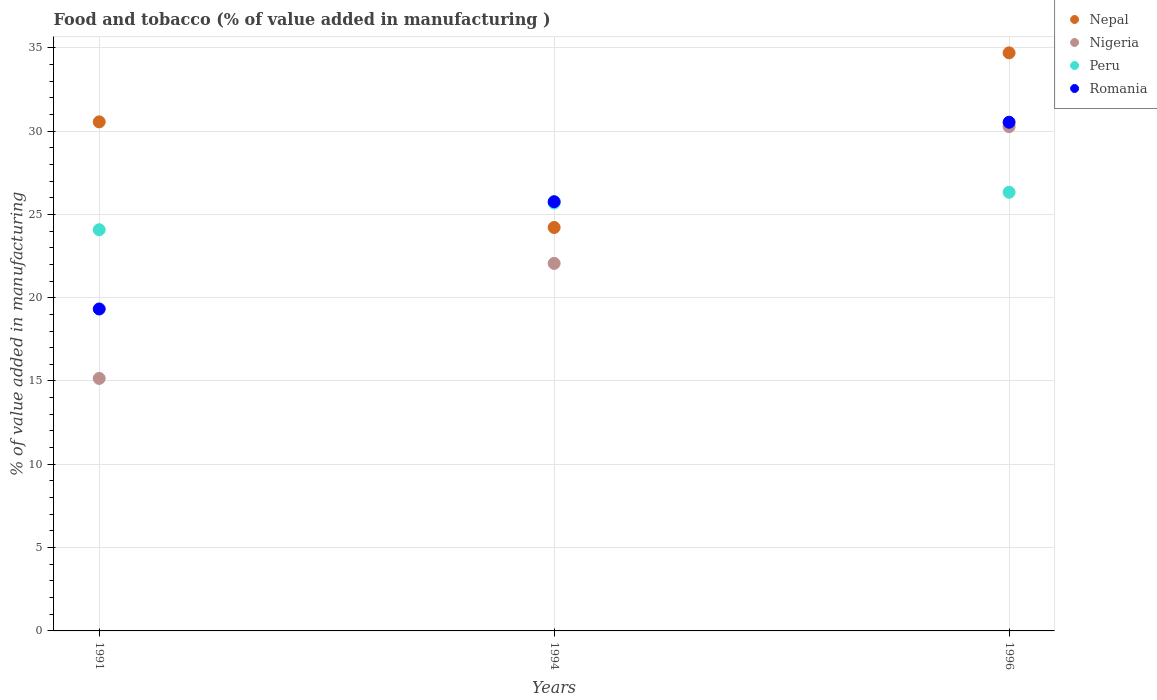How many different coloured dotlines are there?
Your response must be concise. 4. What is the value added in manufacturing food and tobacco in Nepal in 1991?
Your answer should be very brief. 30.55. Across all years, what is the maximum value added in manufacturing food and tobacco in Nigeria?
Your answer should be very brief. 30.27. Across all years, what is the minimum value added in manufacturing food and tobacco in Nigeria?
Provide a succinct answer. 15.15. In which year was the value added in manufacturing food and tobacco in Romania maximum?
Your answer should be very brief. 1996. In which year was the value added in manufacturing food and tobacco in Peru minimum?
Offer a terse response. 1991. What is the total value added in manufacturing food and tobacco in Peru in the graph?
Keep it short and to the point. 76.08. What is the difference between the value added in manufacturing food and tobacco in Nigeria in 1991 and that in 1994?
Ensure brevity in your answer.  -6.9. What is the difference between the value added in manufacturing food and tobacco in Nigeria in 1991 and the value added in manufacturing food and tobacco in Romania in 1996?
Provide a short and direct response. -15.38. What is the average value added in manufacturing food and tobacco in Nepal per year?
Provide a succinct answer. 29.82. In the year 1991, what is the difference between the value added in manufacturing food and tobacco in Romania and value added in manufacturing food and tobacco in Nigeria?
Your answer should be very brief. 4.17. What is the ratio of the value added in manufacturing food and tobacco in Peru in 1994 to that in 1996?
Give a very brief answer. 0.98. Is the difference between the value added in manufacturing food and tobacco in Romania in 1991 and 1994 greater than the difference between the value added in manufacturing food and tobacco in Nigeria in 1991 and 1994?
Provide a succinct answer. Yes. What is the difference between the highest and the second highest value added in manufacturing food and tobacco in Peru?
Offer a terse response. 0.65. What is the difference between the highest and the lowest value added in manufacturing food and tobacco in Nigeria?
Make the answer very short. 15.11. In how many years, is the value added in manufacturing food and tobacco in Romania greater than the average value added in manufacturing food and tobacco in Romania taken over all years?
Provide a succinct answer. 2. Is the sum of the value added in manufacturing food and tobacco in Nepal in 1991 and 1996 greater than the maximum value added in manufacturing food and tobacco in Nigeria across all years?
Offer a very short reply. Yes. Is it the case that in every year, the sum of the value added in manufacturing food and tobacco in Romania and value added in manufacturing food and tobacco in Peru  is greater than the value added in manufacturing food and tobacco in Nigeria?
Provide a succinct answer. Yes. Does the value added in manufacturing food and tobacco in Peru monotonically increase over the years?
Offer a very short reply. Yes. Is the value added in manufacturing food and tobacco in Nepal strictly greater than the value added in manufacturing food and tobacco in Peru over the years?
Offer a very short reply. No. Is the value added in manufacturing food and tobacco in Nepal strictly less than the value added in manufacturing food and tobacco in Nigeria over the years?
Your response must be concise. No. How many dotlines are there?
Ensure brevity in your answer.  4. How many years are there in the graph?
Provide a succinct answer. 3. What is the difference between two consecutive major ticks on the Y-axis?
Provide a short and direct response. 5. Does the graph contain grids?
Provide a short and direct response. Yes. Where does the legend appear in the graph?
Offer a terse response. Top right. How many legend labels are there?
Ensure brevity in your answer.  4. How are the legend labels stacked?
Offer a very short reply. Vertical. What is the title of the graph?
Offer a terse response. Food and tobacco (% of value added in manufacturing ). Does "Malawi" appear as one of the legend labels in the graph?
Keep it short and to the point. No. What is the label or title of the X-axis?
Your response must be concise. Years. What is the label or title of the Y-axis?
Make the answer very short. % of value added in manufacturing. What is the % of value added in manufacturing in Nepal in 1991?
Offer a very short reply. 30.55. What is the % of value added in manufacturing of Nigeria in 1991?
Your answer should be very brief. 15.15. What is the % of value added in manufacturing of Peru in 1991?
Your answer should be very brief. 24.08. What is the % of value added in manufacturing of Romania in 1991?
Offer a very short reply. 19.32. What is the % of value added in manufacturing of Nepal in 1994?
Your answer should be very brief. 24.21. What is the % of value added in manufacturing of Nigeria in 1994?
Give a very brief answer. 22.06. What is the % of value added in manufacturing in Peru in 1994?
Give a very brief answer. 25.68. What is the % of value added in manufacturing of Romania in 1994?
Offer a very short reply. 25.76. What is the % of value added in manufacturing of Nepal in 1996?
Give a very brief answer. 34.69. What is the % of value added in manufacturing of Nigeria in 1996?
Offer a very short reply. 30.27. What is the % of value added in manufacturing in Peru in 1996?
Offer a terse response. 26.33. What is the % of value added in manufacturing of Romania in 1996?
Your answer should be compact. 30.53. Across all years, what is the maximum % of value added in manufacturing in Nepal?
Your answer should be very brief. 34.69. Across all years, what is the maximum % of value added in manufacturing of Nigeria?
Provide a short and direct response. 30.27. Across all years, what is the maximum % of value added in manufacturing of Peru?
Ensure brevity in your answer.  26.33. Across all years, what is the maximum % of value added in manufacturing in Romania?
Provide a short and direct response. 30.53. Across all years, what is the minimum % of value added in manufacturing in Nepal?
Give a very brief answer. 24.21. Across all years, what is the minimum % of value added in manufacturing in Nigeria?
Your answer should be compact. 15.15. Across all years, what is the minimum % of value added in manufacturing of Peru?
Offer a terse response. 24.08. Across all years, what is the minimum % of value added in manufacturing in Romania?
Ensure brevity in your answer.  19.32. What is the total % of value added in manufacturing of Nepal in the graph?
Offer a terse response. 89.46. What is the total % of value added in manufacturing in Nigeria in the graph?
Offer a terse response. 67.48. What is the total % of value added in manufacturing of Peru in the graph?
Offer a terse response. 76.08. What is the total % of value added in manufacturing in Romania in the graph?
Provide a short and direct response. 75.61. What is the difference between the % of value added in manufacturing in Nepal in 1991 and that in 1994?
Provide a short and direct response. 6.34. What is the difference between the % of value added in manufacturing in Nigeria in 1991 and that in 1994?
Keep it short and to the point. -6.9. What is the difference between the % of value added in manufacturing in Peru in 1991 and that in 1994?
Ensure brevity in your answer.  -1.6. What is the difference between the % of value added in manufacturing of Romania in 1991 and that in 1994?
Give a very brief answer. -6.44. What is the difference between the % of value added in manufacturing of Nepal in 1991 and that in 1996?
Offer a very short reply. -4.14. What is the difference between the % of value added in manufacturing in Nigeria in 1991 and that in 1996?
Provide a succinct answer. -15.11. What is the difference between the % of value added in manufacturing in Peru in 1991 and that in 1996?
Keep it short and to the point. -2.25. What is the difference between the % of value added in manufacturing of Romania in 1991 and that in 1996?
Provide a short and direct response. -11.21. What is the difference between the % of value added in manufacturing of Nepal in 1994 and that in 1996?
Ensure brevity in your answer.  -10.48. What is the difference between the % of value added in manufacturing of Nigeria in 1994 and that in 1996?
Your answer should be very brief. -8.21. What is the difference between the % of value added in manufacturing of Peru in 1994 and that in 1996?
Make the answer very short. -0.65. What is the difference between the % of value added in manufacturing of Romania in 1994 and that in 1996?
Keep it short and to the point. -4.77. What is the difference between the % of value added in manufacturing of Nepal in 1991 and the % of value added in manufacturing of Nigeria in 1994?
Offer a very short reply. 8.5. What is the difference between the % of value added in manufacturing of Nepal in 1991 and the % of value added in manufacturing of Peru in 1994?
Provide a short and direct response. 4.87. What is the difference between the % of value added in manufacturing in Nepal in 1991 and the % of value added in manufacturing in Romania in 1994?
Your answer should be compact. 4.79. What is the difference between the % of value added in manufacturing in Nigeria in 1991 and the % of value added in manufacturing in Peru in 1994?
Make the answer very short. -10.53. What is the difference between the % of value added in manufacturing in Nigeria in 1991 and the % of value added in manufacturing in Romania in 1994?
Provide a short and direct response. -10.61. What is the difference between the % of value added in manufacturing in Peru in 1991 and the % of value added in manufacturing in Romania in 1994?
Keep it short and to the point. -1.68. What is the difference between the % of value added in manufacturing of Nepal in 1991 and the % of value added in manufacturing of Nigeria in 1996?
Your response must be concise. 0.29. What is the difference between the % of value added in manufacturing in Nepal in 1991 and the % of value added in manufacturing in Peru in 1996?
Your answer should be compact. 4.23. What is the difference between the % of value added in manufacturing of Nepal in 1991 and the % of value added in manufacturing of Romania in 1996?
Offer a very short reply. 0.02. What is the difference between the % of value added in manufacturing of Nigeria in 1991 and the % of value added in manufacturing of Peru in 1996?
Keep it short and to the point. -11.17. What is the difference between the % of value added in manufacturing of Nigeria in 1991 and the % of value added in manufacturing of Romania in 1996?
Provide a succinct answer. -15.38. What is the difference between the % of value added in manufacturing in Peru in 1991 and the % of value added in manufacturing in Romania in 1996?
Provide a short and direct response. -6.45. What is the difference between the % of value added in manufacturing in Nepal in 1994 and the % of value added in manufacturing in Nigeria in 1996?
Make the answer very short. -6.05. What is the difference between the % of value added in manufacturing of Nepal in 1994 and the % of value added in manufacturing of Peru in 1996?
Provide a succinct answer. -2.11. What is the difference between the % of value added in manufacturing in Nepal in 1994 and the % of value added in manufacturing in Romania in 1996?
Keep it short and to the point. -6.32. What is the difference between the % of value added in manufacturing in Nigeria in 1994 and the % of value added in manufacturing in Peru in 1996?
Give a very brief answer. -4.27. What is the difference between the % of value added in manufacturing of Nigeria in 1994 and the % of value added in manufacturing of Romania in 1996?
Provide a succinct answer. -8.47. What is the difference between the % of value added in manufacturing of Peru in 1994 and the % of value added in manufacturing of Romania in 1996?
Offer a very short reply. -4.85. What is the average % of value added in manufacturing in Nepal per year?
Keep it short and to the point. 29.82. What is the average % of value added in manufacturing in Nigeria per year?
Provide a succinct answer. 22.49. What is the average % of value added in manufacturing of Peru per year?
Offer a very short reply. 25.36. What is the average % of value added in manufacturing in Romania per year?
Give a very brief answer. 25.2. In the year 1991, what is the difference between the % of value added in manufacturing of Nepal and % of value added in manufacturing of Nigeria?
Offer a terse response. 15.4. In the year 1991, what is the difference between the % of value added in manufacturing of Nepal and % of value added in manufacturing of Peru?
Keep it short and to the point. 6.48. In the year 1991, what is the difference between the % of value added in manufacturing of Nepal and % of value added in manufacturing of Romania?
Make the answer very short. 11.23. In the year 1991, what is the difference between the % of value added in manufacturing in Nigeria and % of value added in manufacturing in Peru?
Keep it short and to the point. -8.92. In the year 1991, what is the difference between the % of value added in manufacturing in Nigeria and % of value added in manufacturing in Romania?
Make the answer very short. -4.17. In the year 1991, what is the difference between the % of value added in manufacturing in Peru and % of value added in manufacturing in Romania?
Your answer should be very brief. 4.76. In the year 1994, what is the difference between the % of value added in manufacturing in Nepal and % of value added in manufacturing in Nigeria?
Your response must be concise. 2.16. In the year 1994, what is the difference between the % of value added in manufacturing of Nepal and % of value added in manufacturing of Peru?
Offer a terse response. -1.47. In the year 1994, what is the difference between the % of value added in manufacturing of Nepal and % of value added in manufacturing of Romania?
Make the answer very short. -1.55. In the year 1994, what is the difference between the % of value added in manufacturing of Nigeria and % of value added in manufacturing of Peru?
Ensure brevity in your answer.  -3.62. In the year 1994, what is the difference between the % of value added in manufacturing in Nigeria and % of value added in manufacturing in Romania?
Your response must be concise. -3.7. In the year 1994, what is the difference between the % of value added in manufacturing in Peru and % of value added in manufacturing in Romania?
Provide a short and direct response. -0.08. In the year 1996, what is the difference between the % of value added in manufacturing of Nepal and % of value added in manufacturing of Nigeria?
Your answer should be compact. 4.43. In the year 1996, what is the difference between the % of value added in manufacturing in Nepal and % of value added in manufacturing in Peru?
Ensure brevity in your answer.  8.37. In the year 1996, what is the difference between the % of value added in manufacturing in Nepal and % of value added in manufacturing in Romania?
Give a very brief answer. 4.16. In the year 1996, what is the difference between the % of value added in manufacturing in Nigeria and % of value added in manufacturing in Peru?
Your answer should be very brief. 3.94. In the year 1996, what is the difference between the % of value added in manufacturing in Nigeria and % of value added in manufacturing in Romania?
Ensure brevity in your answer.  -0.26. In the year 1996, what is the difference between the % of value added in manufacturing in Peru and % of value added in manufacturing in Romania?
Keep it short and to the point. -4.2. What is the ratio of the % of value added in manufacturing in Nepal in 1991 to that in 1994?
Offer a very short reply. 1.26. What is the ratio of the % of value added in manufacturing in Nigeria in 1991 to that in 1994?
Give a very brief answer. 0.69. What is the ratio of the % of value added in manufacturing in Peru in 1991 to that in 1994?
Your response must be concise. 0.94. What is the ratio of the % of value added in manufacturing of Romania in 1991 to that in 1994?
Your answer should be compact. 0.75. What is the ratio of the % of value added in manufacturing in Nepal in 1991 to that in 1996?
Offer a terse response. 0.88. What is the ratio of the % of value added in manufacturing in Nigeria in 1991 to that in 1996?
Offer a terse response. 0.5. What is the ratio of the % of value added in manufacturing of Peru in 1991 to that in 1996?
Give a very brief answer. 0.91. What is the ratio of the % of value added in manufacturing of Romania in 1991 to that in 1996?
Your response must be concise. 0.63. What is the ratio of the % of value added in manufacturing in Nepal in 1994 to that in 1996?
Offer a very short reply. 0.7. What is the ratio of the % of value added in manufacturing in Nigeria in 1994 to that in 1996?
Give a very brief answer. 0.73. What is the ratio of the % of value added in manufacturing in Peru in 1994 to that in 1996?
Give a very brief answer. 0.98. What is the ratio of the % of value added in manufacturing in Romania in 1994 to that in 1996?
Give a very brief answer. 0.84. What is the difference between the highest and the second highest % of value added in manufacturing in Nepal?
Your answer should be compact. 4.14. What is the difference between the highest and the second highest % of value added in manufacturing in Nigeria?
Give a very brief answer. 8.21. What is the difference between the highest and the second highest % of value added in manufacturing in Peru?
Your answer should be compact. 0.65. What is the difference between the highest and the second highest % of value added in manufacturing of Romania?
Give a very brief answer. 4.77. What is the difference between the highest and the lowest % of value added in manufacturing of Nepal?
Make the answer very short. 10.48. What is the difference between the highest and the lowest % of value added in manufacturing in Nigeria?
Your response must be concise. 15.11. What is the difference between the highest and the lowest % of value added in manufacturing of Peru?
Make the answer very short. 2.25. What is the difference between the highest and the lowest % of value added in manufacturing in Romania?
Your response must be concise. 11.21. 